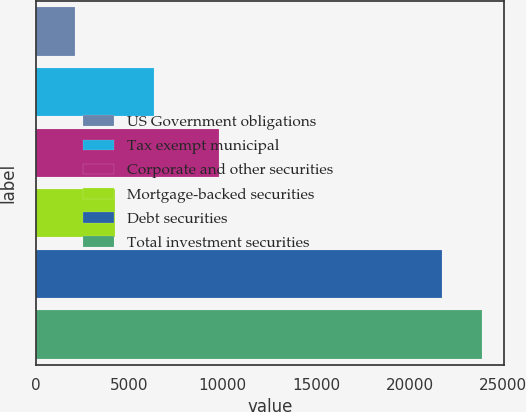<chart> <loc_0><loc_0><loc_500><loc_500><bar_chart><fcel>US Government obligations<fcel>Tax exempt municipal<fcel>Corporate and other securities<fcel>Mortgage-backed securities<fcel>Debt securities<fcel>Total investment securities<nl><fcel>2109<fcel>6351.4<fcel>9809<fcel>4230.2<fcel>21744<fcel>23865.2<nl></chart> 